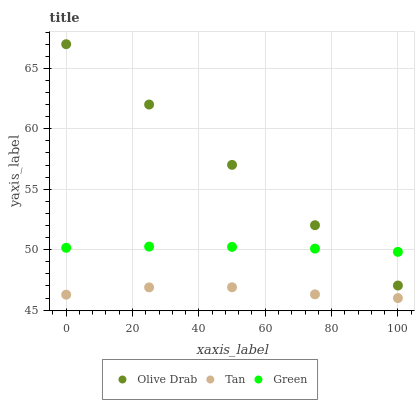Does Tan have the minimum area under the curve?
Answer yes or no. Yes. Does Olive Drab have the maximum area under the curve?
Answer yes or no. Yes. Does Green have the minimum area under the curve?
Answer yes or no. No. Does Green have the maximum area under the curve?
Answer yes or no. No. Is Olive Drab the smoothest?
Answer yes or no. Yes. Is Tan the roughest?
Answer yes or no. Yes. Is Green the smoothest?
Answer yes or no. No. Is Green the roughest?
Answer yes or no. No. Does Tan have the lowest value?
Answer yes or no. Yes. Does Olive Drab have the lowest value?
Answer yes or no. No. Does Olive Drab have the highest value?
Answer yes or no. Yes. Does Green have the highest value?
Answer yes or no. No. Is Tan less than Olive Drab?
Answer yes or no. Yes. Is Green greater than Tan?
Answer yes or no. Yes. Does Green intersect Olive Drab?
Answer yes or no. Yes. Is Green less than Olive Drab?
Answer yes or no. No. Is Green greater than Olive Drab?
Answer yes or no. No. Does Tan intersect Olive Drab?
Answer yes or no. No. 